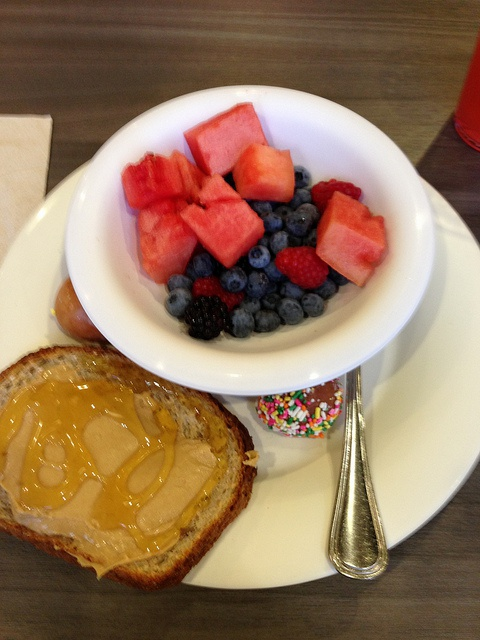Describe the objects in this image and their specific colors. I can see dining table in ivory, maroon, black, and tan tones, bowl in maroon, lightgray, black, salmon, and brown tones, sandwich in maroon, olive, and orange tones, spoon in maroon, olive, tan, gray, and ivory tones, and cup in maroon and purple tones in this image. 